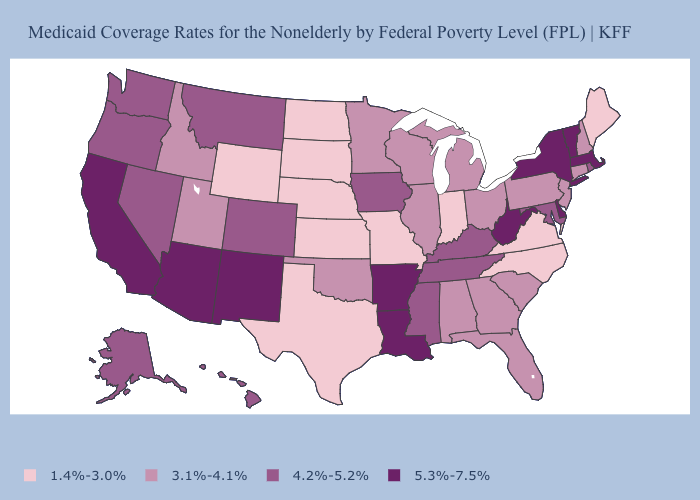Does Maryland have a lower value than Missouri?
Short answer required. No. Does Nebraska have the lowest value in the MidWest?
Keep it brief. Yes. How many symbols are there in the legend?
Quick response, please. 4. Among the states that border Massachusetts , which have the lowest value?
Quick response, please. Connecticut, New Hampshire. Name the states that have a value in the range 4.2%-5.2%?
Answer briefly. Alaska, Colorado, Hawaii, Iowa, Kentucky, Maryland, Mississippi, Montana, Nevada, Oregon, Rhode Island, Tennessee, Washington. What is the value of South Carolina?
Quick response, please. 3.1%-4.1%. Does North Dakota have a lower value than Florida?
Keep it brief. Yes. Among the states that border Mississippi , which have the highest value?
Concise answer only. Arkansas, Louisiana. Which states have the lowest value in the South?
Be succinct. North Carolina, Texas, Virginia. What is the value of Illinois?
Concise answer only. 3.1%-4.1%. Name the states that have a value in the range 3.1%-4.1%?
Be succinct. Alabama, Connecticut, Florida, Georgia, Idaho, Illinois, Michigan, Minnesota, New Hampshire, New Jersey, Ohio, Oklahoma, Pennsylvania, South Carolina, Utah, Wisconsin. What is the value of West Virginia?
Answer briefly. 5.3%-7.5%. Name the states that have a value in the range 4.2%-5.2%?
Short answer required. Alaska, Colorado, Hawaii, Iowa, Kentucky, Maryland, Mississippi, Montana, Nevada, Oregon, Rhode Island, Tennessee, Washington. Does the map have missing data?
Give a very brief answer. No. Which states hav the highest value in the MidWest?
Concise answer only. Iowa. 